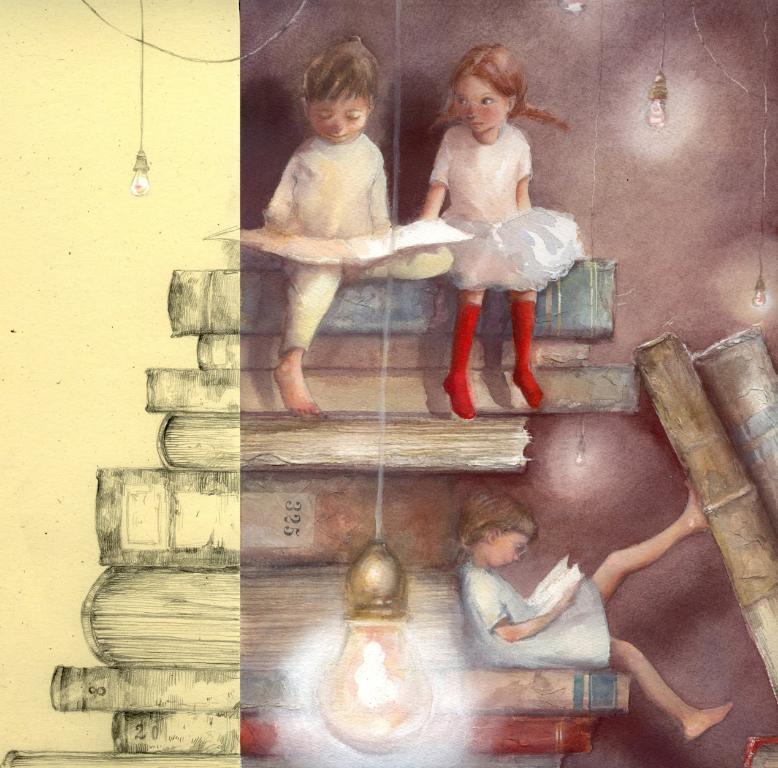Can you describe this image briefly? In this image we can see a painting of three children sitting on the books, here we can see the bulbs. This part of the image is in brown color and the part of the image is in light yellow color. 